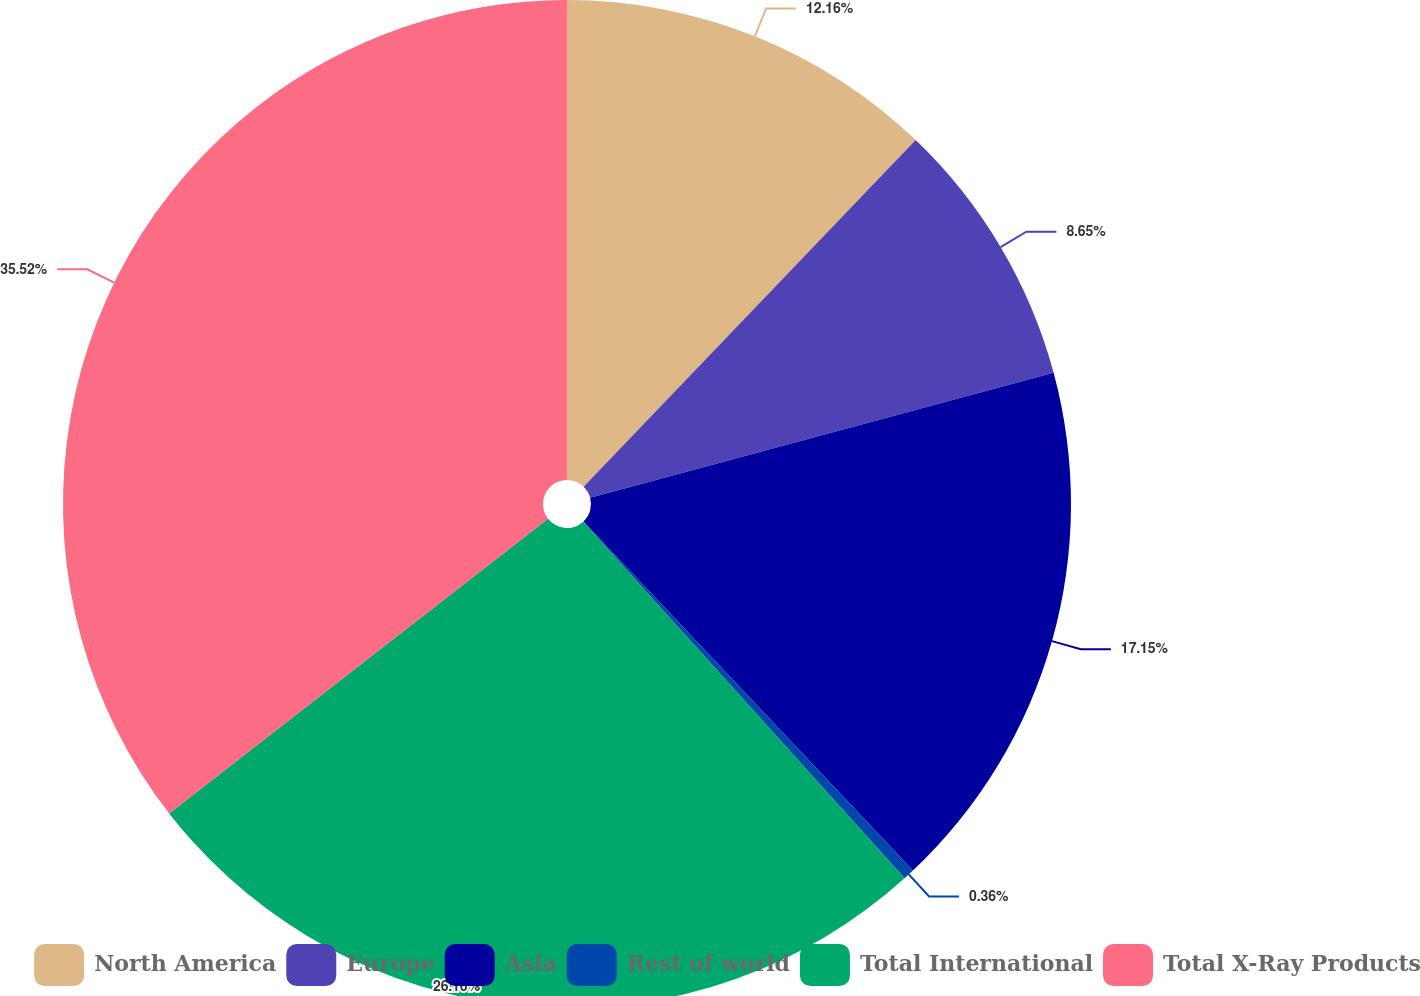<chart> <loc_0><loc_0><loc_500><loc_500><pie_chart><fcel>North America<fcel>Europe<fcel>Asia<fcel>Rest of world<fcel>Total International<fcel>Total X-Ray Products<nl><fcel>12.16%<fcel>8.65%<fcel>17.15%<fcel>0.36%<fcel>26.16%<fcel>35.52%<nl></chart> 